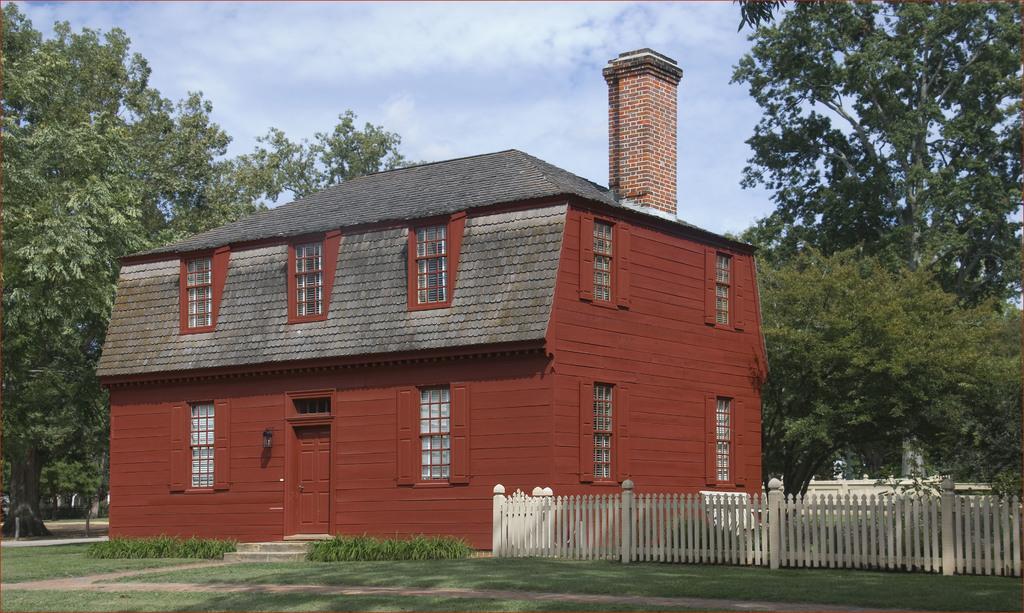How would you summarize this image in a sentence or two? In this picture we can see the grass, fence, trees, plants, building with windows, door and in the background we can see the sky with clouds. 